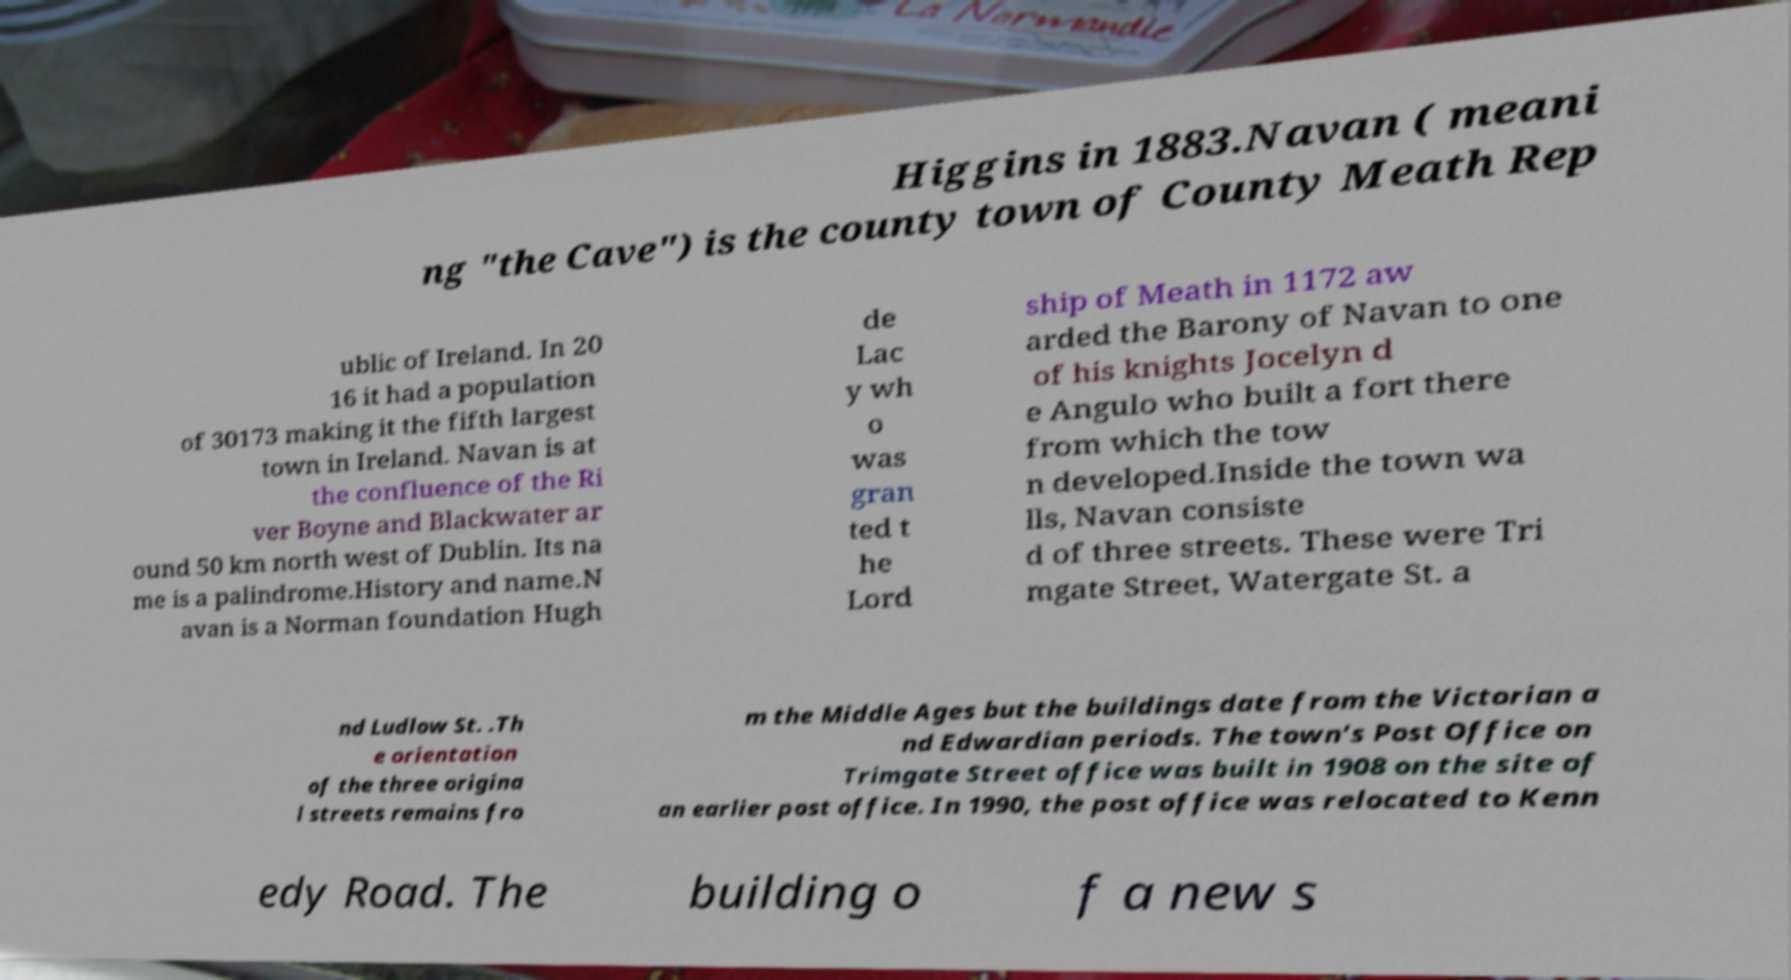Please identify and transcribe the text found in this image. Higgins in 1883.Navan ( meani ng "the Cave") is the county town of County Meath Rep ublic of Ireland. In 20 16 it had a population of 30173 making it the fifth largest town in Ireland. Navan is at the confluence of the Ri ver Boyne and Blackwater ar ound 50 km north west of Dublin. Its na me is a palindrome.History and name.N avan is a Norman foundation Hugh de Lac y wh o was gran ted t he Lord ship of Meath in 1172 aw arded the Barony of Navan to one of his knights Jocelyn d e Angulo who built a fort there from which the tow n developed.Inside the town wa lls, Navan consiste d of three streets. These were Tri mgate Street, Watergate St. a nd Ludlow St. .Th e orientation of the three origina l streets remains fro m the Middle Ages but the buildings date from the Victorian a nd Edwardian periods. The town’s Post Office on Trimgate Street office was built in 1908 on the site of an earlier post office. In 1990, the post office was relocated to Kenn edy Road. The building o f a new s 